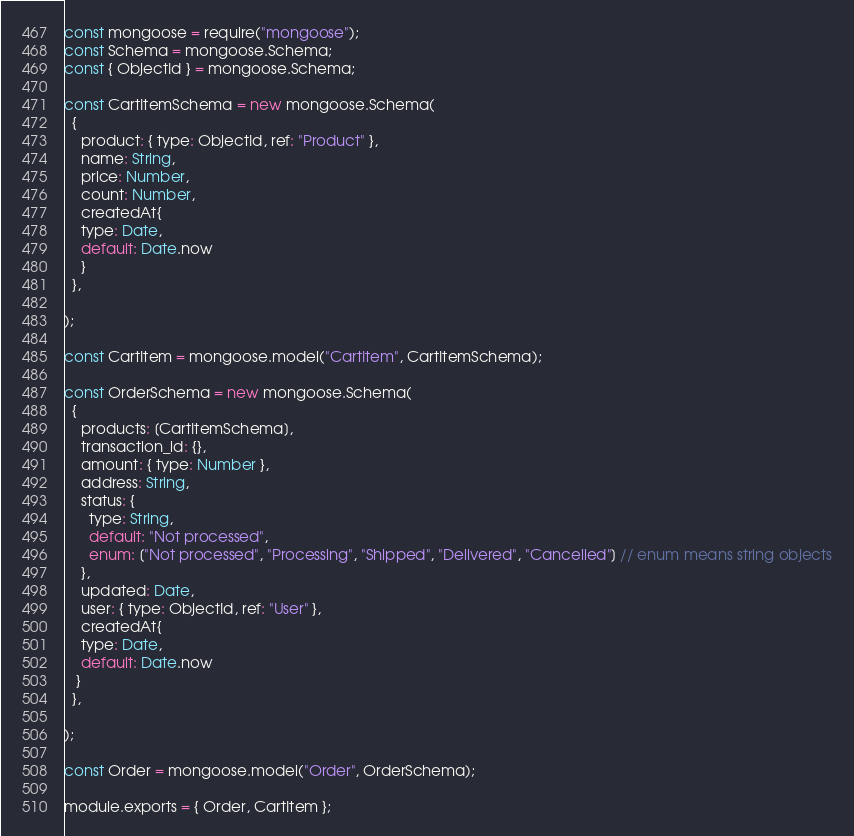<code> <loc_0><loc_0><loc_500><loc_500><_JavaScript_>const mongoose = require("mongoose");
const Schema = mongoose.Schema;
const { ObjectId } = mongoose.Schema;

const CartItemSchema = new mongoose.Schema(
  {
    product: { type: ObjectId, ref: "Product" },
    name: String,
    price: Number,
    count: Number,
    createdAt{
    type: Date,
    default: Date.now
    }
  },
  
);

const CartItem = mongoose.model("CartItem", CartItemSchema);

const OrderSchema = new mongoose.Schema(
  {
    products: [CartItemSchema],
    transaction_id: {},
    amount: { type: Number },
    address: String,
    status: {
      type: String,
      default: "Not processed",
      enum: ["Not processed", "Processing", "Shipped", "Delivered", "Cancelled"] // enum means string objects
    },
    updated: Date,
    user: { type: ObjectId, ref: "User" },
    createdAt{
    type: Date,
    default: Date.now
   }
  },
  
);

const Order = mongoose.model("Order", OrderSchema);

module.exports = { Order, CartItem };</code> 